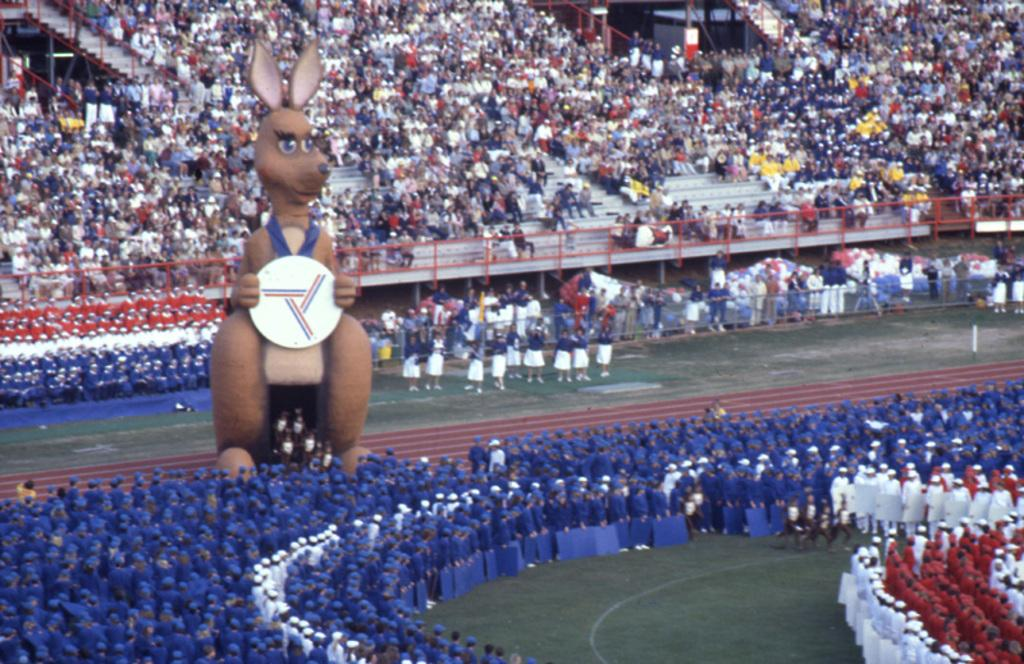What is the main subject of the image? There is a kangaroo sculpture in the image. Where is the sculpture located? The sculpture is in a stadium. What are some people doing in the stadium? Some people are standing and some are sitting in the stadium. What type of structure is present in the stadium? There are iron grilles in the stadium. Are there any other objects in the stadium besides the kangaroo sculpture and the iron grilles? Yes, there are other objects in the stadium. What time is the lunchroom open in the image? There is no mention of a lunchroom in the image, so we cannot determine when it might be open. Is there a hose visible in the image? There is no hose present in the image. 